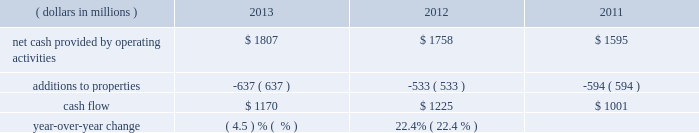General market conditions affecting trust asset performance , future discount rates based on average yields of high quality corporate bonds and our decisions regarding certain elective provisions of the we currently project that we will make total u.s .
And foreign benefit plan contributions in 2014 of approximately $ 57 million .
Actual 2014 contributions could be different from our current projections , as influenced by our decision to undertake discretionary funding of our benefit trusts versus other competing investment priorities , future changes in government requirements , trust asset performance , renewals of union contracts , or higher-than-expected health care claims cost experience .
We measure cash flow as net cash provided by operating activities reduced by expenditures for property additions .
We use this non-gaap financial measure of cash flow to focus management and investors on the amount of cash available for debt repayment , dividend distributions , acquisition opportunities , and share repurchases .
Our cash flow metric is reconciled to the most comparable gaap measure , as follows: .
Year-over-year change ( 4.5 ) % (  % ) 22.4% ( 22.4 % ) the decrease in cash flow ( as defined ) in 2013 compared to 2012 was due primarily to higher capital expenditures .
The increase in cash flow in 2012 compared to 2011 was driven by improved performance in working capital resulting from the one-time benefit derived from the pringles acquisition , as well as changes in the level of capital expenditures during the three-year period .
Investing activities our net cash used in investing activities for 2013 amounted to $ 641 million , a decrease of $ 2604 million compared with 2012 primarily attributable to the $ 2668 million acquisition of pringles in 2012 .
Capital spending in 2013 included investments in our supply chain infrastructure , and to support capacity requirements in certain markets , including pringles .
In addition , we continued the investment in our information technology infrastructure related to the reimplementation and upgrade of our sap platform .
Net cash used in investing activities of $ 3245 million in 2012 increased by $ 2658 million compared with 2011 , due to the acquisition of pringles in 2012 .
Cash paid for additions to properties as a percentage of net sales has increased to 4.3% ( 4.3 % ) in 2013 , from 3.8% ( 3.8 % ) in 2012 , which was a decrease from 4.5% ( 4.5 % ) in financing activities our net cash used by financing activities was $ 1141 million for 2013 , compared to net cash provided by financing activities of $ 1317 million for 2012 and net cash used in financing activities of $ 957 million for 2011 .
The increase in cash provided from financing activities in 2012 compared to 2013 and 2011 , was primarily due to the issuance of debt related to the acquisition of pringles .
Total debt was $ 7.4 billion at year-end 2013 and $ 7.9 billion at year-end 2012 .
In february 2013 , we issued $ 250 million of two-year floating-rate u.s .
Dollar notes , and $ 400 million of ten-year 2.75% ( 2.75 % ) u.s .
Dollar notes , resulting in aggregate net proceeds after debt discount of $ 645 million .
The proceeds from these notes were used for general corporate purposes , including , together with cash on hand , repayment of the $ 750 million aggregate principal amount of our 4.25% ( 4.25 % ) u.s .
Dollar notes due march 2013 .
In may 2012 , we issued $ 350 million of three-year 1.125% ( 1.125 % ) u.s .
Dollar notes , $ 400 million of five-year 1.75% ( 1.75 % ) u.s .
Dollar notes and $ 700 million of ten-year 3.125% ( 3.125 % ) u.s .
Dollar notes , resulting in aggregate net proceeds after debt discount of $ 1.442 billion .
The proceeds of these notes were used for general corporate purposes , including financing a portion of the acquisition of pringles .
In may 2012 , we issued cdn .
$ 300 million of two-year 2.10% ( 2.10 % ) fixed rate canadian dollar notes , using the proceeds from these notes for general corporate purposes , which included repayment of intercompany debt .
This repayment resulted in cash available to be used for a portion of the acquisition of pringles .
In december 2012 , we repaid $ 750 million five-year 5.125% ( 5.125 % ) u.s .
Dollar notes at maturity with commercial paper .
In april 2011 , we repaid $ 945 million ten-year 6.60% ( 6.60 % ) u.s .
Dollar notes at maturity with commercial paper .
In may 2011 , we issued $ 400 million of seven-year 3.25% ( 3.25 % ) fixed rate u.s .
Dollar notes , using the proceeds of $ 397 million for general corporate purposes and repayment of commercial paper .
In november 2011 , we issued $ 500 million of five-year 1.875% ( 1.875 % ) fixed rate u .
Dollar notes , using the proceeds of $ 498 million for general corporate purposes and repayment of commercial paper. .
In 2013 , what percent of net cash from operations is retained as cash flow? 
Computations: (1170 / 1807)
Answer: 0.64748. 